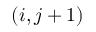<formula> <loc_0><loc_0><loc_500><loc_500>( i , j + 1 )</formula> 